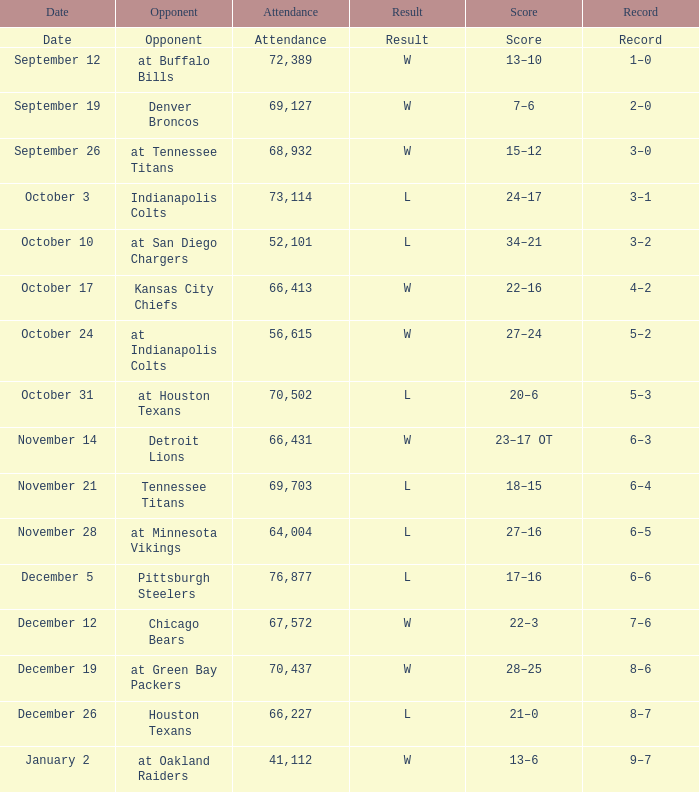What score has October 31 as the date? 20–6. 